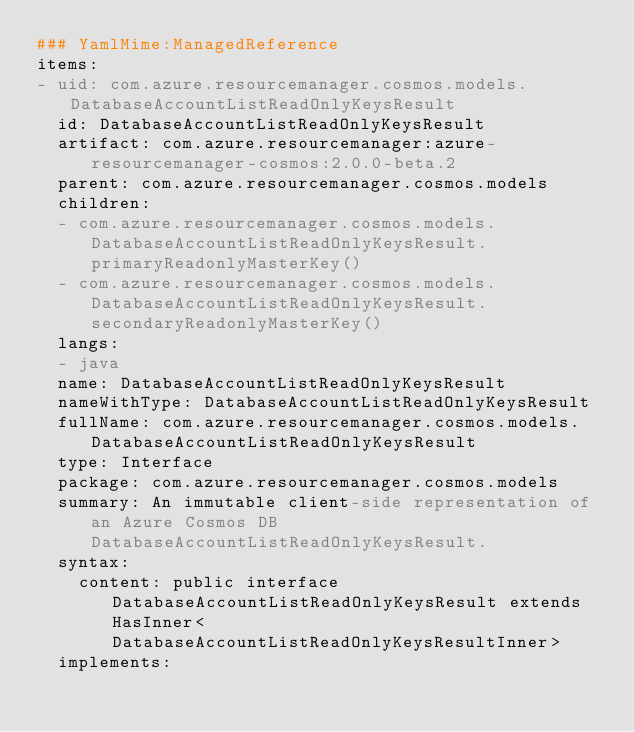Convert code to text. <code><loc_0><loc_0><loc_500><loc_500><_YAML_>### YamlMime:ManagedReference
items:
- uid: com.azure.resourcemanager.cosmos.models.DatabaseAccountListReadOnlyKeysResult
  id: DatabaseAccountListReadOnlyKeysResult
  artifact: com.azure.resourcemanager:azure-resourcemanager-cosmos:2.0.0-beta.2
  parent: com.azure.resourcemanager.cosmos.models
  children:
  - com.azure.resourcemanager.cosmos.models.DatabaseAccountListReadOnlyKeysResult.primaryReadonlyMasterKey()
  - com.azure.resourcemanager.cosmos.models.DatabaseAccountListReadOnlyKeysResult.secondaryReadonlyMasterKey()
  langs:
  - java
  name: DatabaseAccountListReadOnlyKeysResult
  nameWithType: DatabaseAccountListReadOnlyKeysResult
  fullName: com.azure.resourcemanager.cosmos.models.DatabaseAccountListReadOnlyKeysResult
  type: Interface
  package: com.azure.resourcemanager.cosmos.models
  summary: An immutable client-side representation of an Azure Cosmos DB DatabaseAccountListReadOnlyKeysResult.
  syntax:
    content: public interface DatabaseAccountListReadOnlyKeysResult extends HasInner<DatabaseAccountListReadOnlyKeysResultInner>
  implements:</code> 